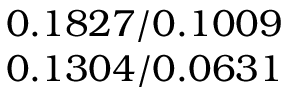Convert formula to latex. <formula><loc_0><loc_0><loc_500><loc_500>\begin{array} { c } { 0 . 1 8 2 7 / 0 . 1 0 0 9 } \\ { 0 . 1 3 0 4 / 0 . 0 6 3 1 } \end{array}</formula> 